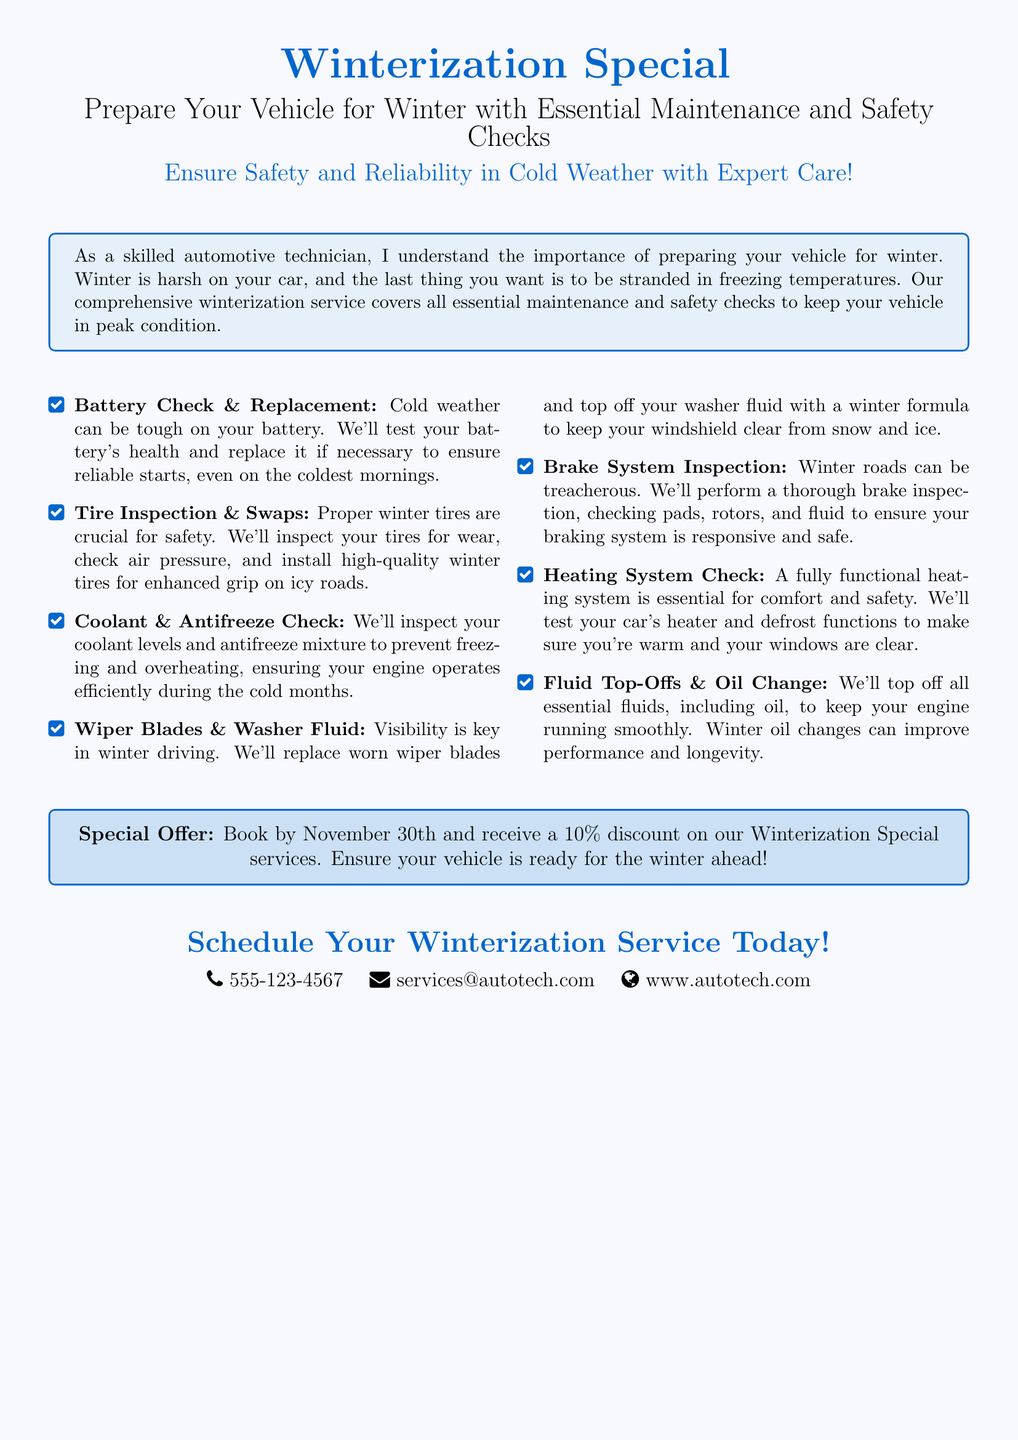What is the title of the special offer? The title of the special offer is displayed prominently and describes the service being promoted.
Answer: Winterization Special What is the deadline to book the winterization service for a discount? The document contains a specific date, which is the last day to avail the discount for the advertised services.
Answer: November 30th What percentage discount is offered for booking the winterization services? The discount percentage is indicated in the promotion section of the advertisement.
Answer: 10% Which part of the vehicle is checked for coolant and antifreeze? The document lists various maintenance checks, one of which pertains specifically to the engine’s coolant system.
Answer: Engine What are the two contact methods provided in the advertisement? The document provides both phone and email contact methods for scheduling the service.
Answer: Phone and email Why is a battery check recommended during winter? The document explains how cold weather impacts battery performance, suggesting it's essential for reliability.
Answer: Cold weather can be tough on your battery How many essential maintenance checks are listed in the document? The document enumerates several specific services included in the winterization package.
Answer: Seven What visual tool is used to highlight the services offered? The document uses a specific layout format to present the services and promotions visually appealingly.
Answer: Tcolorbox What type of service is recommended for the heating system? The heating system is mentioned as needing a specific function test to ensure comfort and safety during winter.
Answer: Heating System Check 